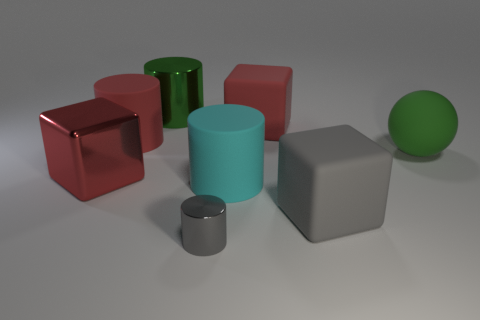Subtract all metallic blocks. How many blocks are left? 2 Add 2 large shiny objects. How many objects exist? 10 Subtract 3 cylinders. How many cylinders are left? 1 Add 7 big green metallic things. How many big green metallic things exist? 8 Subtract all gray cylinders. How many cylinders are left? 3 Subtract 0 blue cylinders. How many objects are left? 8 Subtract all balls. How many objects are left? 7 Subtract all blue cylinders. Subtract all purple blocks. How many cylinders are left? 4 Subtract all purple blocks. How many red cylinders are left? 1 Subtract all tiny metal objects. Subtract all large green rubber balls. How many objects are left? 6 